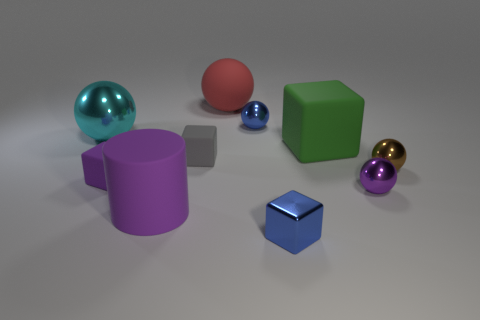What shape is the tiny rubber object that is the same color as the large matte cylinder?
Your response must be concise. Cube. Do the rubber cylinder and the tiny metallic ball that is in front of the brown ball have the same color?
Make the answer very short. Yes. What is the material of the sphere that is both right of the big red matte sphere and behind the cyan object?
Your response must be concise. Metal. How many small objects are brown shiny cubes or cyan objects?
Offer a terse response. 0. The red matte thing is what size?
Offer a very short reply. Large. The small purple matte object is what shape?
Your answer should be compact. Cube. Are there any other things that are the same shape as the gray matte object?
Your answer should be very brief. Yes. Are there fewer red rubber spheres in front of the big cyan shiny ball than spheres?
Ensure brevity in your answer.  Yes. There is a rubber thing that is behind the blue sphere; is its color the same as the large metal object?
Offer a very short reply. No. How many rubber objects are big cyan objects or tiny blue cylinders?
Offer a very short reply. 0. 